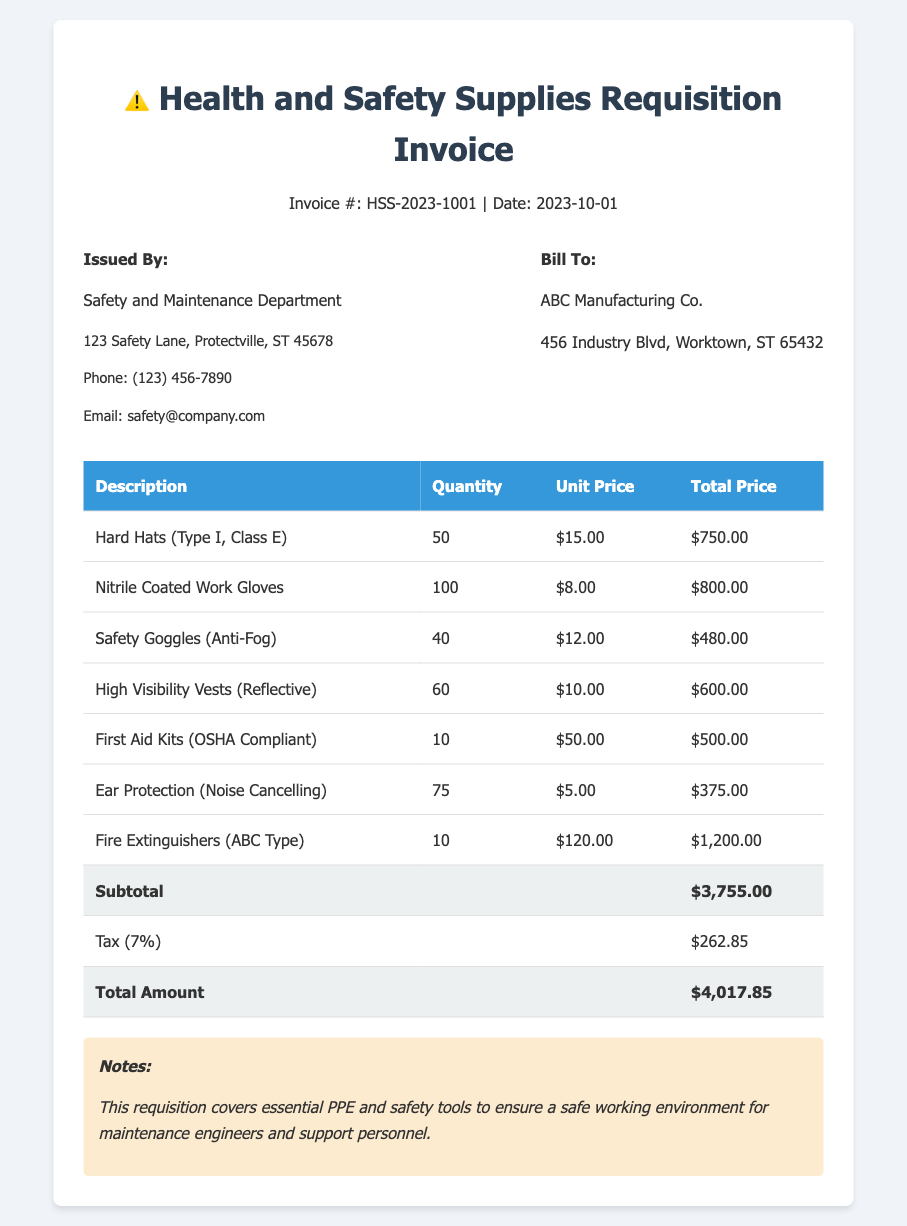What is the invoice number? The invoice number is clearly stated at the top of the document.
Answer: HSS-2023-1001 Who issued the invoice? The document specifies the issuing department responsible for the invoice.
Answer: Safety and Maintenance Department What is the date of the invoice? The date is prominently displayed within the header section of the invoice.
Answer: 2023-10-01 How many hard hats were purchased? The quantity of hard hats purchased is listed in the table itemizing the supplies.
Answer: 50 What is the subtotal amount? The subtotal is calculated before tax and is shown at the bottom of the table.
Answer: $3,755.00 What is the tax percentage applied? The tax information is provided within the invoice details, specifying the applicable rate.
Answer: 7% How many first aid kits were ordered? The quantity for first aid kits can be directly found within the table detailing the purchases.
Answer: 10 What should this requisition ensure? The notes section provides context on the purpose of the requisition listed in the document.
Answer: A safe working environment What type of fire extinguishers were ordered? The description of fire extinguishers purchased is mentioned in the table.
Answer: ABC Type 